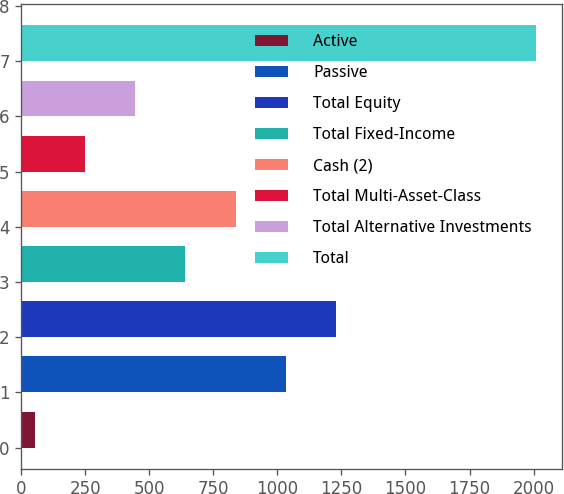<chart> <loc_0><loc_0><loc_500><loc_500><bar_chart><fcel>Active<fcel>Passive<fcel>Total Equity<fcel>Total Fixed-Income<fcel>Cash (2)<fcel>Total Multi-Asset-Class<fcel>Total Alternative Investments<fcel>Total<nl><fcel>54<fcel>1032<fcel>1227.6<fcel>640.8<fcel>836.4<fcel>249.6<fcel>445.2<fcel>2010<nl></chart> 